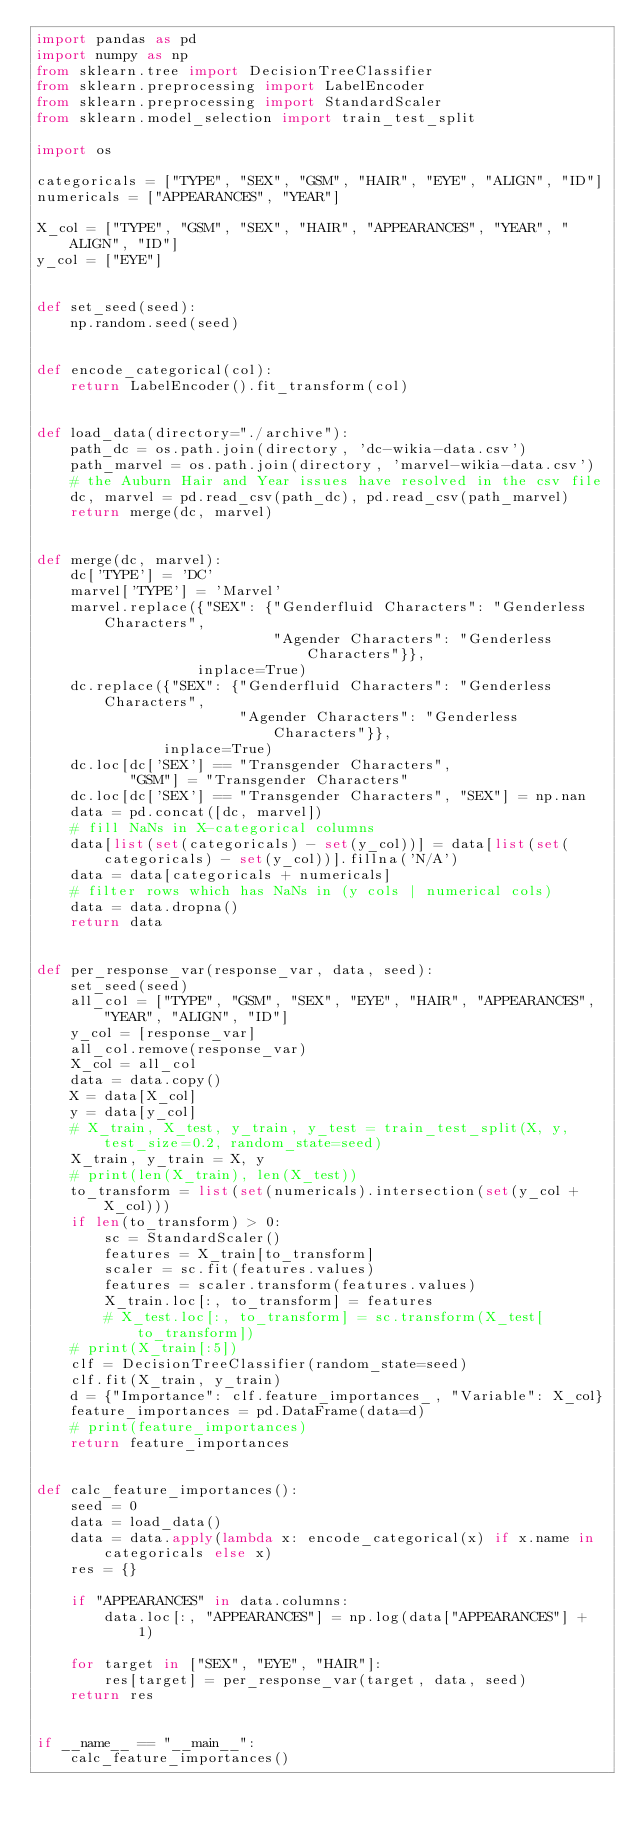<code> <loc_0><loc_0><loc_500><loc_500><_Python_>import pandas as pd
import numpy as np
from sklearn.tree import DecisionTreeClassifier
from sklearn.preprocessing import LabelEncoder
from sklearn.preprocessing import StandardScaler
from sklearn.model_selection import train_test_split

import os

categoricals = ["TYPE", "SEX", "GSM", "HAIR", "EYE", "ALIGN", "ID"]
numericals = ["APPEARANCES", "YEAR"]

X_col = ["TYPE", "GSM", "SEX", "HAIR", "APPEARANCES", "YEAR", "ALIGN", "ID"]
y_col = ["EYE"]


def set_seed(seed):
    np.random.seed(seed)


def encode_categorical(col):
    return LabelEncoder().fit_transform(col)


def load_data(directory="./archive"):
    path_dc = os.path.join(directory, 'dc-wikia-data.csv')
    path_marvel = os.path.join(directory, 'marvel-wikia-data.csv')
    # the Auburn Hair and Year issues have resolved in the csv file
    dc, marvel = pd.read_csv(path_dc), pd.read_csv(path_marvel)
    return merge(dc, marvel)


def merge(dc, marvel):
    dc['TYPE'] = 'DC'
    marvel['TYPE'] = 'Marvel'
    marvel.replace({"SEX": {"Genderfluid Characters": "Genderless Characters",
                            "Agender Characters": "Genderless Characters"}},
                   inplace=True)
    dc.replace({"SEX": {"Genderfluid Characters": "Genderless Characters",
                        "Agender Characters": "Genderless Characters"}},
               inplace=True)
    dc.loc[dc['SEX'] == "Transgender Characters",
           "GSM"] = "Transgender Characters"
    dc.loc[dc['SEX'] == "Transgender Characters", "SEX"] = np.nan
    data = pd.concat([dc, marvel])
    # fill NaNs in X-categorical columns
    data[list(set(categoricals) - set(y_col))] = data[list(set(categoricals) - set(y_col))].fillna('N/A')
    data = data[categoricals + numericals]
    # filter rows which has NaNs in (y cols | numerical cols)
    data = data.dropna()
    return data


def per_response_var(response_var, data, seed):
    set_seed(seed)
    all_col = ["TYPE", "GSM", "SEX", "EYE", "HAIR", "APPEARANCES", "YEAR", "ALIGN", "ID"]
    y_col = [response_var]
    all_col.remove(response_var)
    X_col = all_col
    data = data.copy()
    X = data[X_col]
    y = data[y_col]
    # X_train, X_test, y_train, y_test = train_test_split(X, y, test_size=0.2, random_state=seed)
    X_train, y_train = X, y
    # print(len(X_train), len(X_test))
    to_transform = list(set(numericals).intersection(set(y_col + X_col)))
    if len(to_transform) > 0:
        sc = StandardScaler()
        features = X_train[to_transform]
        scaler = sc.fit(features.values)
        features = scaler.transform(features.values)
        X_train.loc[:, to_transform] = features
        # X_test.loc[:, to_transform] = sc.transform(X_test[to_transform])
    # print(X_train[:5])
    clf = DecisionTreeClassifier(random_state=seed)
    clf.fit(X_train, y_train)
    d = {"Importance": clf.feature_importances_, "Variable": X_col}
    feature_importances = pd.DataFrame(data=d)
    # print(feature_importances)
    return feature_importances


def calc_feature_importances():
    seed = 0
    data = load_data()
    data = data.apply(lambda x: encode_categorical(x) if x.name in categoricals else x)
    res = {}

    if "APPEARANCES" in data.columns:
        data.loc[:, "APPEARANCES"] = np.log(data["APPEARANCES"] + 1)

    for target in ["SEX", "EYE", "HAIR"]:
        res[target] = per_response_var(target, data, seed)
    return res


if __name__ == "__main__":
    calc_feature_importances()
</code> 